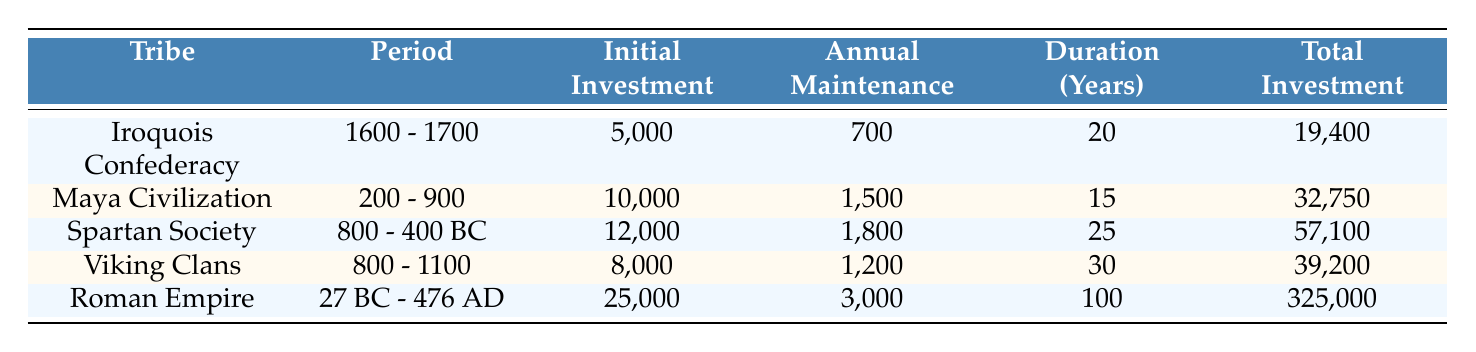What was the initial investment for the Roman Empire? The Roman Empire's initial investment can be found in the "Initial Investment" column of the table. It states that the initial investment is 25,000.
Answer: 25,000 Which tribe had the longest duration for their societal investment in defense mechanisms? The "Duration (Years)" column shows the duration for each tribe. The Roman Empire has the longest duration at 100 years, which is longer than any other tribe listed.
Answer: Roman Empire What is the total investment made by the Iroquois Confederacy? The total investment for the Iroquois Confederacy can be found in the "Total Investment" column, which indicates the amount is 19,400.
Answer: 19,400 Is the annual maintenance cost for the Maya Civilization greater than that for the Viking Clans? The "Annual Maintenance" column displays the annual costs. The Maya Civilization has an annual maintenance of 1,500, while the Viking Clans have 1,200. Since 1,500 is greater than 1,200, the answer is yes.
Answer: Yes What is the total investment over time for Spartan Society compared to Iroquois Confederacy? From the "Total Investment" column, the Spartan Society has a total investment of 57,100, while the Iroquois Confederacy has 19,400. The difference can be calculated as 57,100 - 19,400 = 37,700. The Spartan Society invested significantly more.
Answer: 37,700 What was the average annual maintenance cost across all tribes? To find the average, sum the annual maintenance costs: 700 + 1500 + 1800 + 1200 + 3000 = 8200. Then divide by the number of tribes (5): 8200 / 5 = 1640.
Answer: 1640 Was the total investment for the Viking Clans lower than for the Maya Civilization? The total investment for the Viking Clans is shown as 39,200, and for the Maya Civilization, it is 32,750. Since 39,200 is higher than 32,750, the answer is no.
Answer: No How does the initial investment in the Roman Empire compare to that in the Iroquois Confederacy? The "Initial Investment" column indicates that the Roman Empire invested 25,000 while the Iroquois Confederacy invested 5,000. Thus, comparing these shows that the Roman Empire invested 20,000 more.
Answer: 20,000 What percentage of the total investment for the Roman Empire is attributed to annual maintenance? First, calculate the total annual maintenance over the duration of 100 years, which is 3,000 * 100 = 300,000. Thus, total investment for the Roman Empire is 325,000. The percentage is calculated as (300,000 / 325,000) * 100 ≈ 92.31%.
Answer: 92.31% 